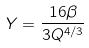Convert formula to latex. <formula><loc_0><loc_0><loc_500><loc_500>Y = \frac { 1 6 \beta } { 3 Q ^ { 4 / 3 } }</formula> 